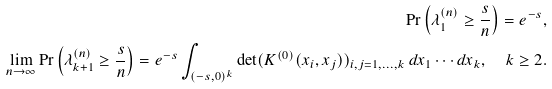<formula> <loc_0><loc_0><loc_500><loc_500>\Pr \left ( \lambda _ { 1 } ^ { ( n ) } \geq \frac { s } { n } \right ) = e ^ { - s } , \\ \lim _ { n \to \infty } \Pr \left ( \lambda _ { k + 1 } ^ { ( n ) } \geq \frac { s } { n } \right ) = e ^ { - s } \int _ { ( - s , 0 ) ^ { k } } \det ( K ^ { ( 0 ) } ( x _ { i } , x _ { j } ) ) _ { i , j = 1 , \dots , k } \, d x _ { 1 } \cdots d x _ { k } , \quad k \geq 2 .</formula> 